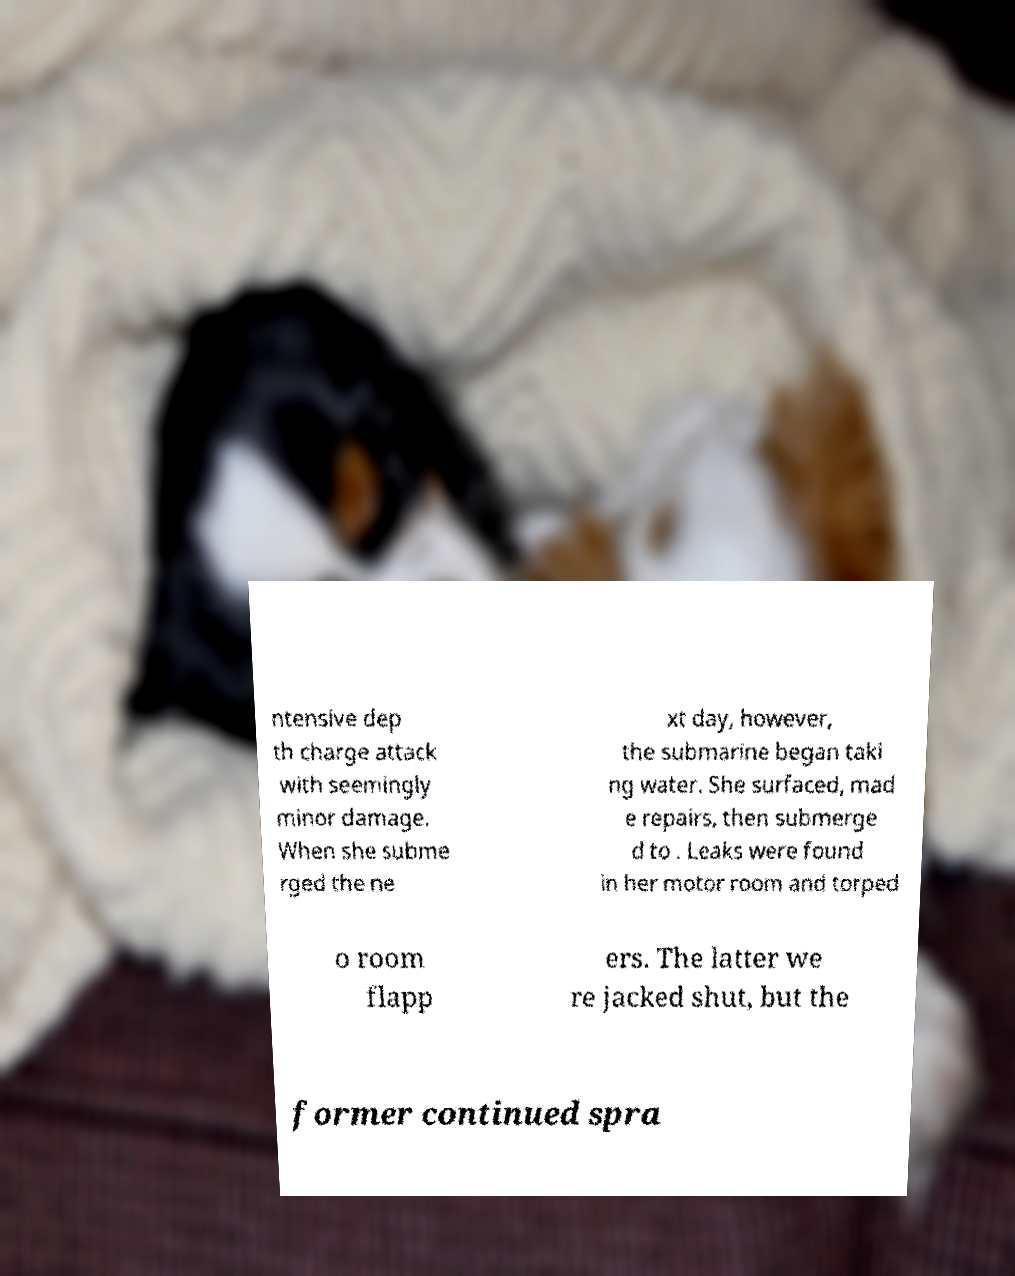For documentation purposes, I need the text within this image transcribed. Could you provide that? ntensive dep th charge attack with seemingly minor damage. When she subme rged the ne xt day, however, the submarine began taki ng water. She surfaced, mad e repairs, then submerge d to . Leaks were found in her motor room and torped o room flapp ers. The latter we re jacked shut, but the former continued spra 